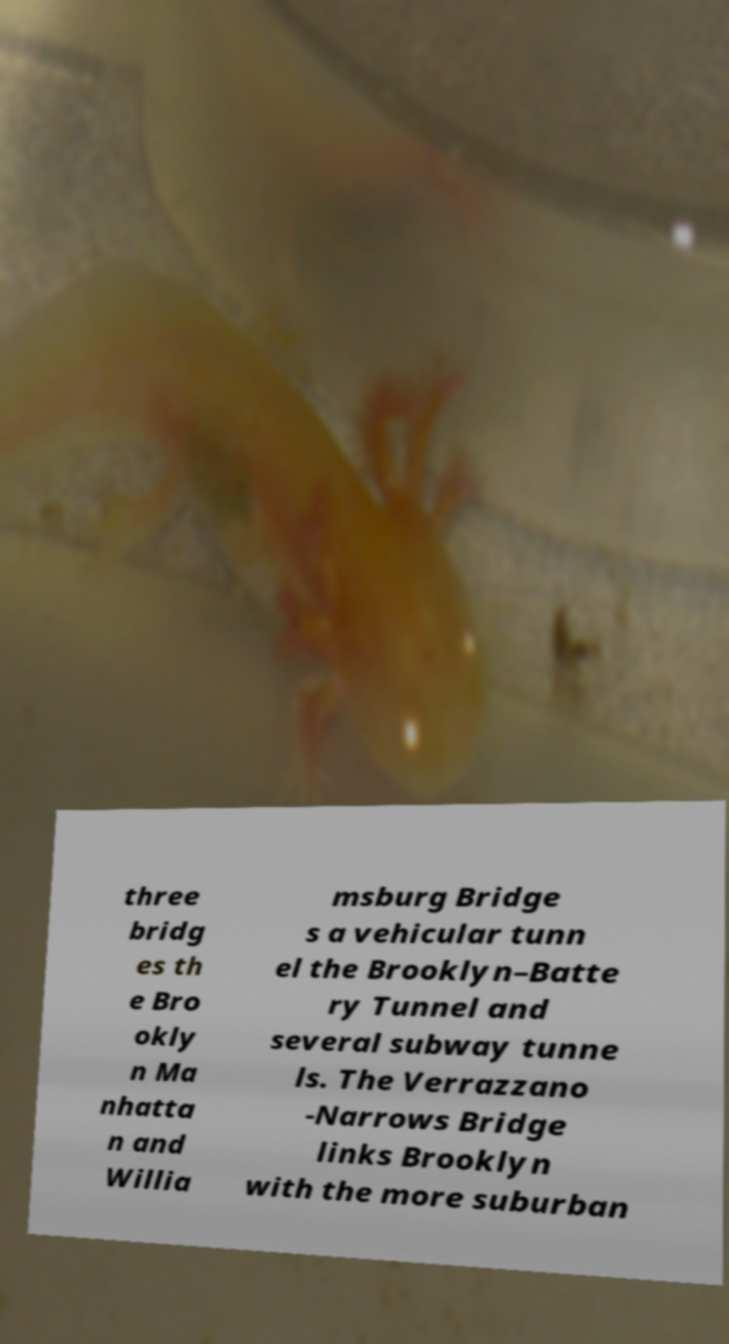Can you accurately transcribe the text from the provided image for me? three bridg es th e Bro okly n Ma nhatta n and Willia msburg Bridge s a vehicular tunn el the Brooklyn–Batte ry Tunnel and several subway tunne ls. The Verrazzano -Narrows Bridge links Brooklyn with the more suburban 